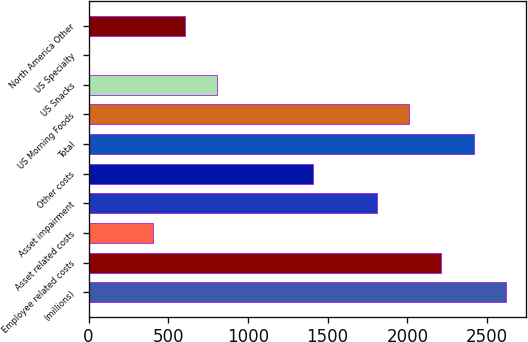Convert chart. <chart><loc_0><loc_0><loc_500><loc_500><bar_chart><fcel>(millions)<fcel>Employee related costs<fcel>Asset related costs<fcel>Asset impairment<fcel>Other costs<fcel>Total<fcel>US Morning Foods<fcel>US Snacks<fcel>US Specialty<fcel>North America Other<nl><fcel>2616<fcel>2214<fcel>405<fcel>1812<fcel>1410<fcel>2415<fcel>2013<fcel>807<fcel>3<fcel>606<nl></chart> 